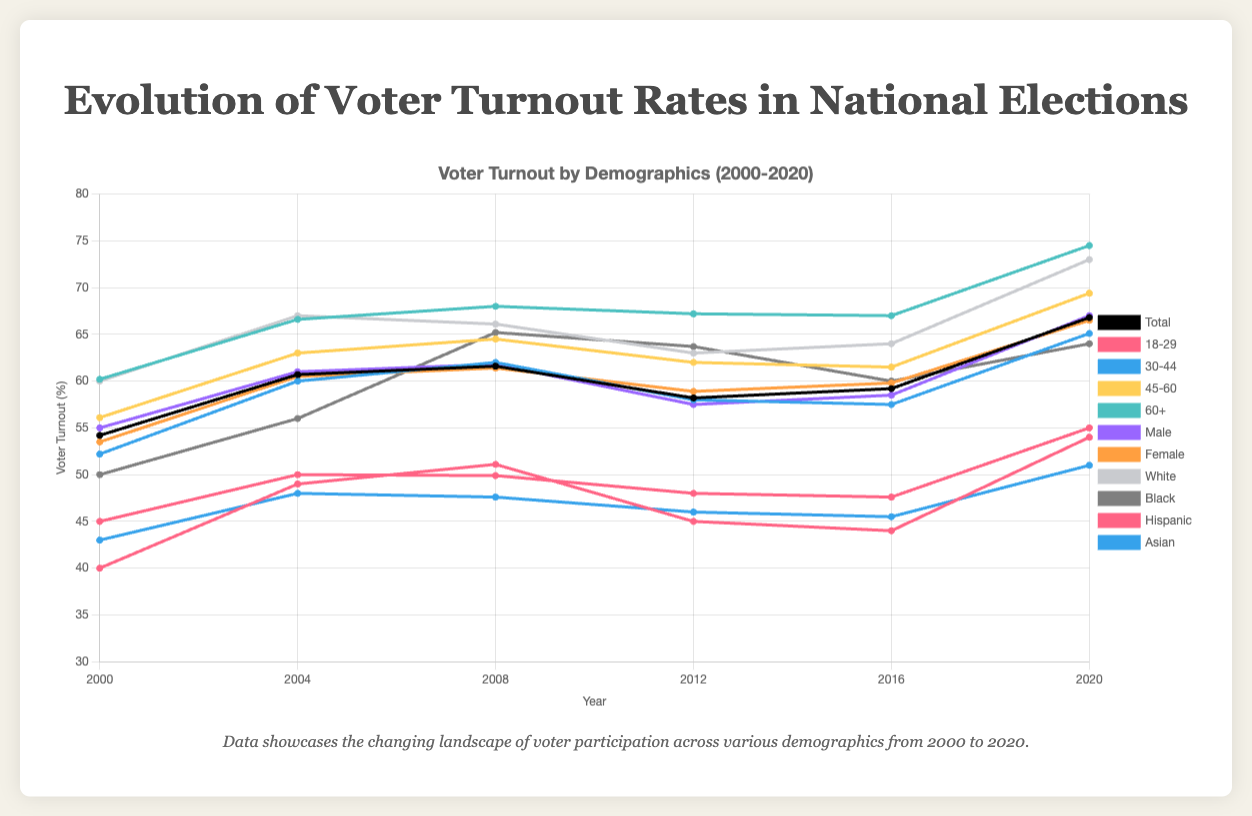What was the total voter turnout in 2020? Look for the data line corresponding to the year 2020 and identify the total voter turnout. The value is shown beside the line representing all demographics combined.
Answer: 66.8 Which age group had the highest voter turnout in 2020? Go to the year 2020, then look at the turnout rates for all age groups and see which one is the highest. In the figure, the "60+" age group has the highest turnout.
Answer: 60+ What's the difference in voter turnout between the "18-29" age group and the "60+" age group in 2000? Compare the voter turnout rates between "18-29" and "60+" in the year 2000. The calculation is 60.2 - 40.0.
Answer: 20.2 How did voter turnout for women change from 2000 to 2020? Track the line for the female demographic from 2000 to 2020. Notice the values at these points and the difference. Voter turnout for women was 53.5% in 2000 and increased to 66.5% in 2020.
Answer: Increased by 13% Which demographic showed the most significant increase in voter turnout from 2016 to 2020? Compare the increase in turnout for each demographic group from 2016 to 2020. The most significant increase is in the "60+" age group, going from 67.0% to 74.5%, an increase of 7.5%.
Answer: 60+ Is the voter turnout rate of the "30-44" age group in 2004 greater than or equal to the "45-60" age group in 2000? Compare the voter turnout rate of the "30-44" age group in 2004 (60.0%) to the "45-60" age group in 2000 (56.1%).
Answer: Yes Which demographic had a higher turnout in 2008, Black or Asian voters? Compare the voter turnout percentage for Black and Asian demographics in the year 2008. Black voters had a turnout of 65.2%, whereas Asian voters had a turnout of 47.6%.
Answer: Black voters What is the total increase in voter turnout for the "18-29" age group from 2000 to 2020? Find the voter turnout for the "18-29" age group in 2000 (40.0%) and in 2020 (54.0%), then compute the increase.
Answer: 14.0 What was the trend in voter turnout for Hispanic voters from 2000 to 2020? Look at the points for Hispanic voter turnout from 2000 to 2020. The trend started at 45.0% in 2000 and ended at 55.0% in 2020, showing an increasing trend overall.
Answer: Increasing trend 